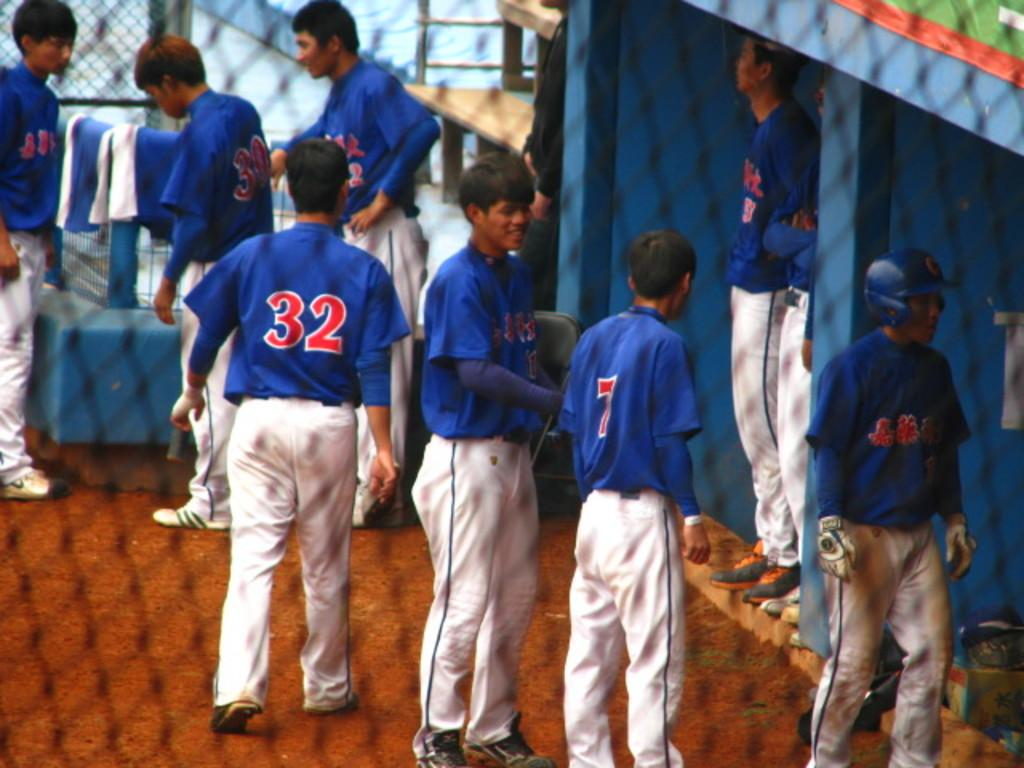<image>
Present a compact description of the photo's key features. Baseball players are in a dugout including one player wearing a number 32. 